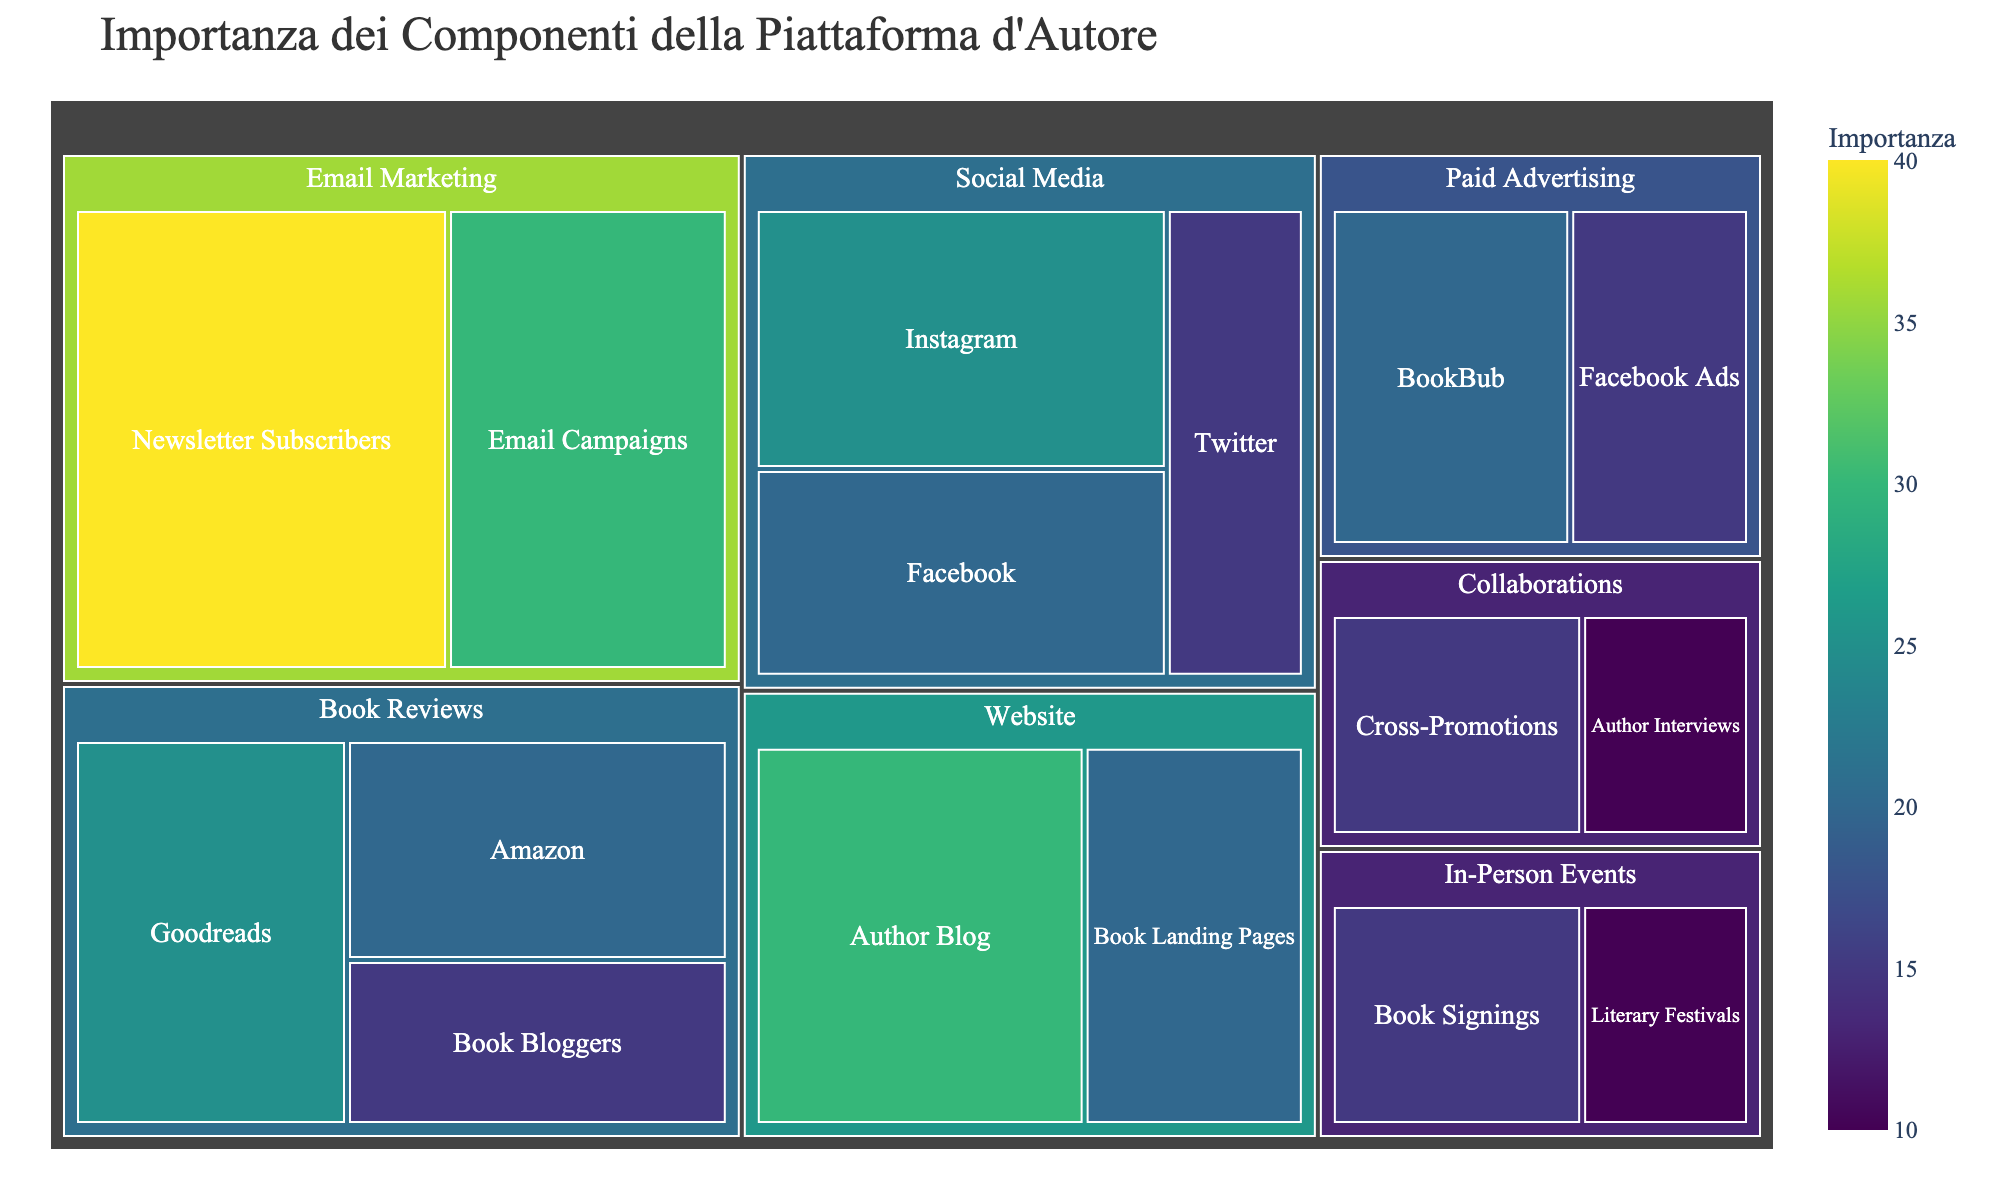What's the most important single subcategory in the figure? To determine the most important single subcategory, look for the subcategory with the highest value of 'Importance' in the treemap. According to the data, the subcategory with the highest importance value is 'Newsletter Subscribers' with an importance of 40.
Answer: Newsletter Subscribers Which category contains the subcategory 'Author Blog'? To find which category contains 'Author Blog', you need to locate 'Author Blog' in the treemap and observe its parent category. From the data, 'Author Blog' belongs to the 'Website' category.
Answer: Website What is the total importance of the 'Social Media' subcategories? To calculate the total importance of the 'Social Media' subcategories, sum the importance values of Instagram, Facebook, and Twitter. This is 25 + 20 + 15 = 60.
Answer: 60 Among 'Paid Advertising' subcategories, which one is more important? To identify the more important subcategory between 'BookBub' and 'Facebook Ads' under 'Paid Advertising', compare their importance values. 'BookBub' has 20, while 'Facebook Ads' has 15.
Answer: BookBub Which category has the lowest total importance, and what is that value? To find the category with the lowest total importance, sum the 'Importance' values of each category and compare them. 'In-Person Events' has 15 (Book Signings) + 10 (Literary Festivals) = 25, which is the lowest.
Answer: In-Person Events, 25 What is the combined importance of 'Book Reviews' and 'Email Marketing' categories? To find the combined importance, sum the total imports of the 'Book Reviews' and 'Email Marketing' categories. 'Book Reviews' has 25 (Goodreads) + 20 (Amazon) + 15 (Book Bloggers) = 60, and 'Email Marketing' has 40 (Newsletter Subscribers) + 30 (Email Campaigns) = 70. Thus, the combined importance is 60 + 70 = 130.
Answer: 130 How many subcategories have a lower importance than 'Twitter'? To count the subcategories with importance values lower than 'Twitter' (15), list all subcategories and their importance values. Subcategories with lower importance values are 'Literary Festivals' (10) and 'Author Interviews' (10), which totals 2 subcategories.
Answer: 2 Which subcategory under 'Collaborations' is less important? To find the less important subcategory under 'Collaborations', compare the importance values of 'Cross-Promotions' and 'Author Interviews'. 'Author Interviews' has a value of 10, which is less than 'Cross-Promotions' (15).
Answer: Author Interviews Are there more subcategories with an importance value greater than or equal to 20 or less? Count the number of subcategories with importance values greater than or equal to 20 and those with values less than 20. There are 8 subcategories with values greater than or equal to 20 (Instagram, Facebook, Author Blog, Book Landing Pages, Newsletter Subscribers, Email Campaigns, Goodreads, Amazon) and 8 with values less (Twitter, Book Bloggers, Book Signings, Literary Festivals, Cross-Promotions, Author Interviews, BookBub, Facebook Ads). Since the counts are the same, neither is greater.
Answer: Equal 